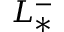Convert formula to latex. <formula><loc_0><loc_0><loc_500><loc_500>L _ { * } ^ { - }</formula> 